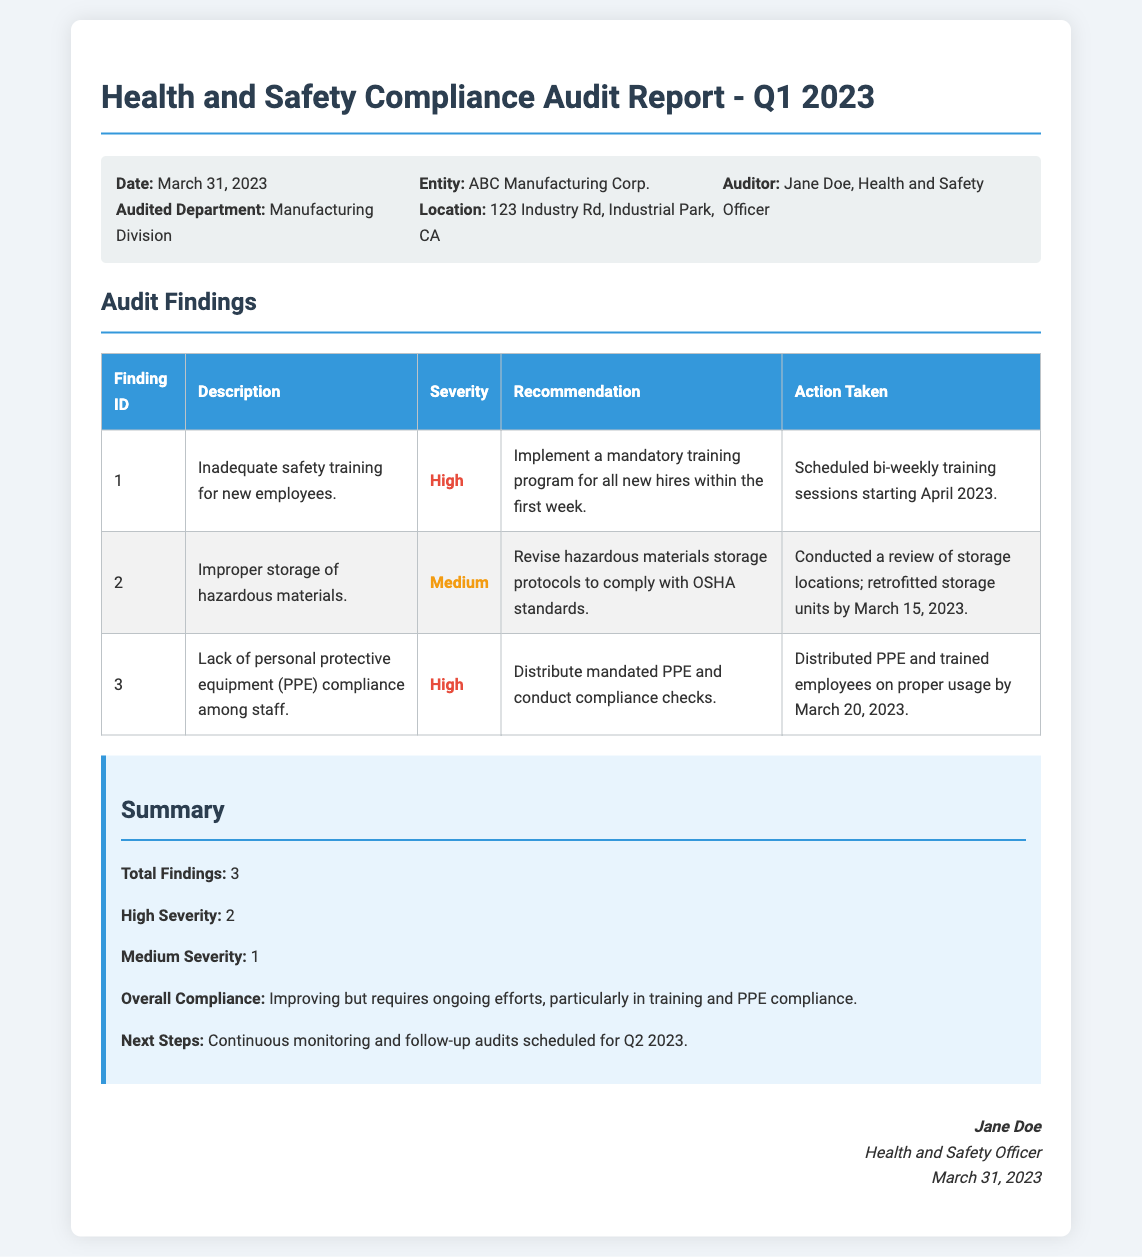What is the date of the audit report? The date of the audit report is mentioned in the document header.
Answer: March 31, 2023 Who conducted the audit? The name of the auditor is specified in the audit info section.
Answer: Jane Doe What is the total number of findings? The total findings are summarized at the end of the audit findings section.
Answer: 3 How many findings had high severity? It is indicated in the summary section based on the severity classification provided earlier.
Answer: 2 What action was taken for the lack of PPE compliance? The specific action taken regarding PPE is detailed in the audit findings table.
Answer: Distributed PPE and trained employees on proper usage by March 20, 2023 What department was audited? The audited department is listed in the audit info section.
Answer: Manufacturing Division What were the recommendations for improper storage of hazardous materials? The recommendations are included in the findings table.
Answer: Revise hazardous materials storage protocols to comply with OSHA standards What is the overall compliance status mentioned in the summary? The overall compliance status is highlighted in the summary section.
Answer: Improving but requires ongoing efforts, particularly in training and PPE compliance 